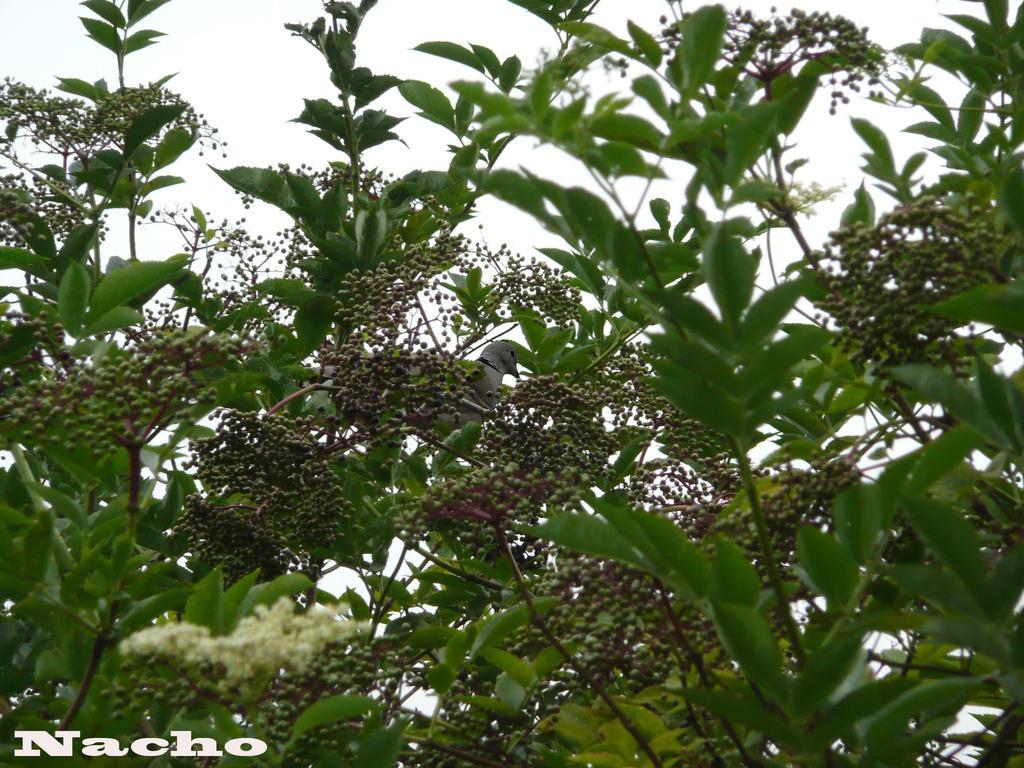Could you give a brief overview of what you see in this image? In this picture I can see in the bottom left hand side there is a watermark, in the middle there are trees. At the top there is the sky. 